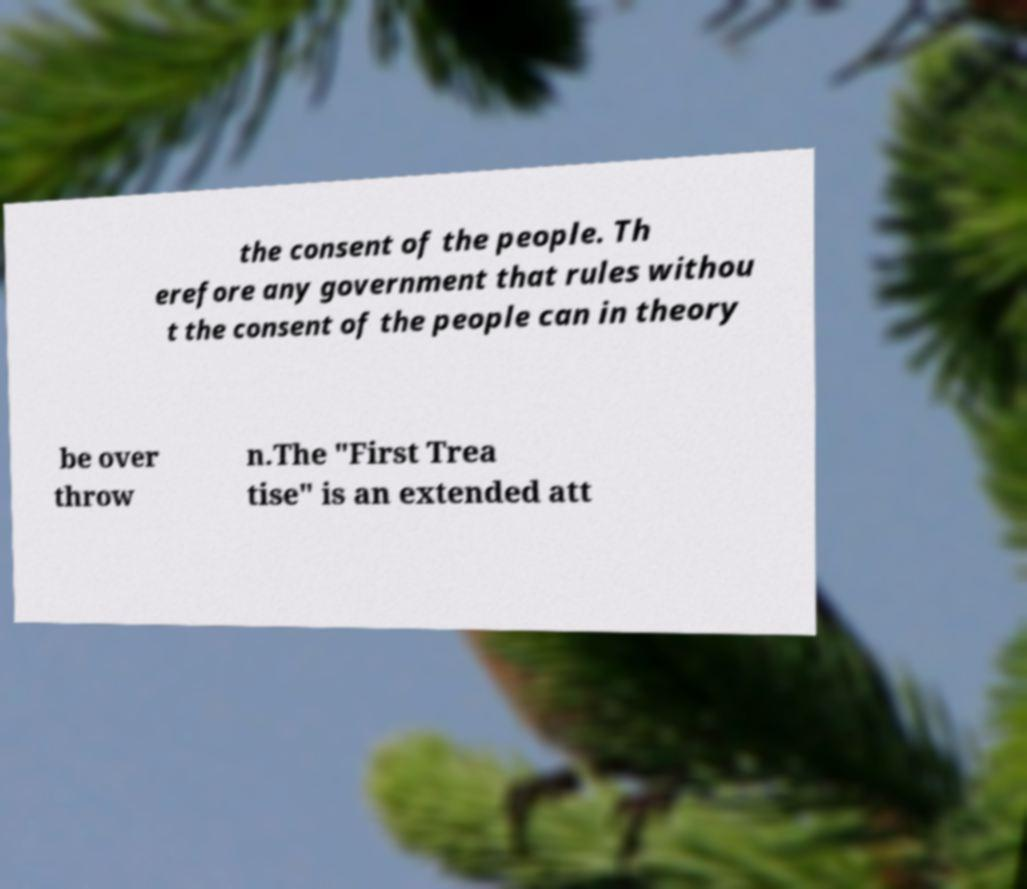There's text embedded in this image that I need extracted. Can you transcribe it verbatim? the consent of the people. Th erefore any government that rules withou t the consent of the people can in theory be over throw n.The "First Trea tise" is an extended att 